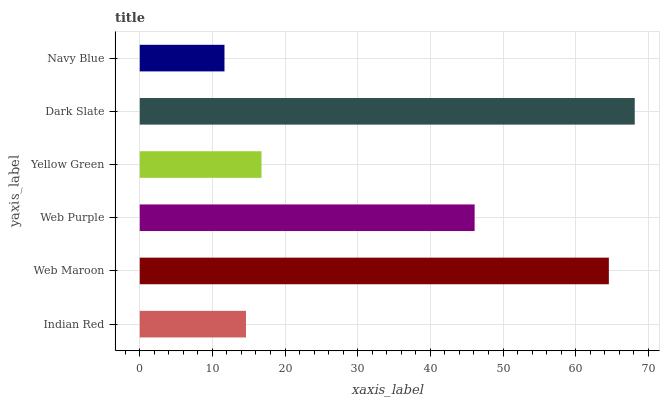Is Navy Blue the minimum?
Answer yes or no. Yes. Is Dark Slate the maximum?
Answer yes or no. Yes. Is Web Maroon the minimum?
Answer yes or no. No. Is Web Maroon the maximum?
Answer yes or no. No. Is Web Maroon greater than Indian Red?
Answer yes or no. Yes. Is Indian Red less than Web Maroon?
Answer yes or no. Yes. Is Indian Red greater than Web Maroon?
Answer yes or no. No. Is Web Maroon less than Indian Red?
Answer yes or no. No. Is Web Purple the high median?
Answer yes or no. Yes. Is Yellow Green the low median?
Answer yes or no. Yes. Is Dark Slate the high median?
Answer yes or no. No. Is Web Maroon the low median?
Answer yes or no. No. 